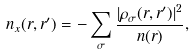Convert formula to latex. <formula><loc_0><loc_0><loc_500><loc_500>n _ { x } ( r , r ^ { \prime } ) = - \sum _ { \sigma } \frac { | \rho _ { \sigma } ( r , r ^ { \prime } ) | ^ { 2 } } { n ( r ) } ,</formula> 